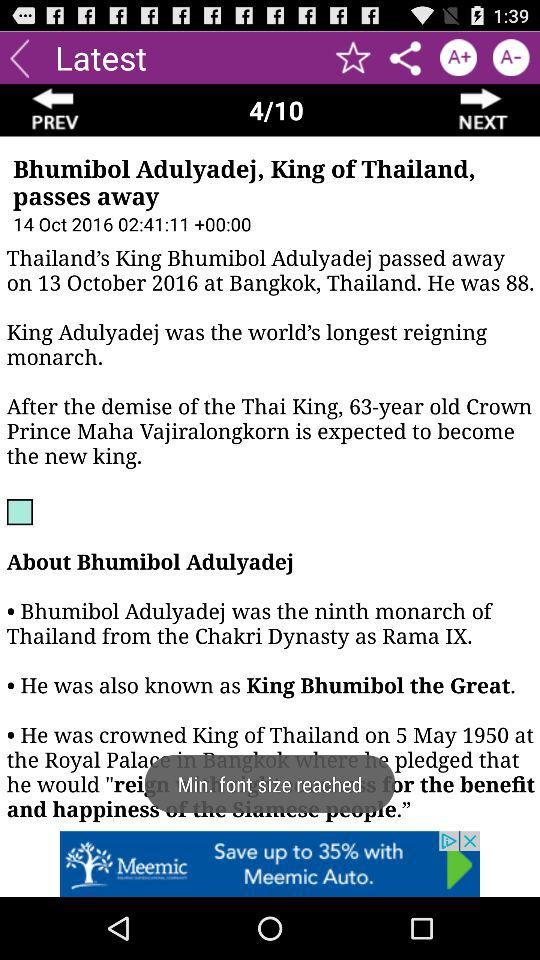When did the King of Thailand pass away? The King of Thailand passed away on October 13, 2016. 